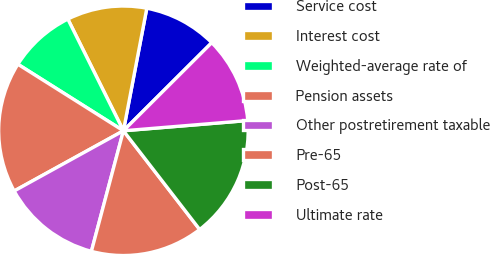Convert chart to OTSL. <chart><loc_0><loc_0><loc_500><loc_500><pie_chart><fcel>Service cost<fcel>Interest cost<fcel>Weighted-average rate of<fcel>Pension assets<fcel>Other postretirement taxable<fcel>Pre-65<fcel>Post-65<fcel>Ultimate rate<nl><fcel>9.52%<fcel>10.35%<fcel>8.7%<fcel>16.97%<fcel>12.85%<fcel>14.6%<fcel>15.84%<fcel>11.17%<nl></chart> 